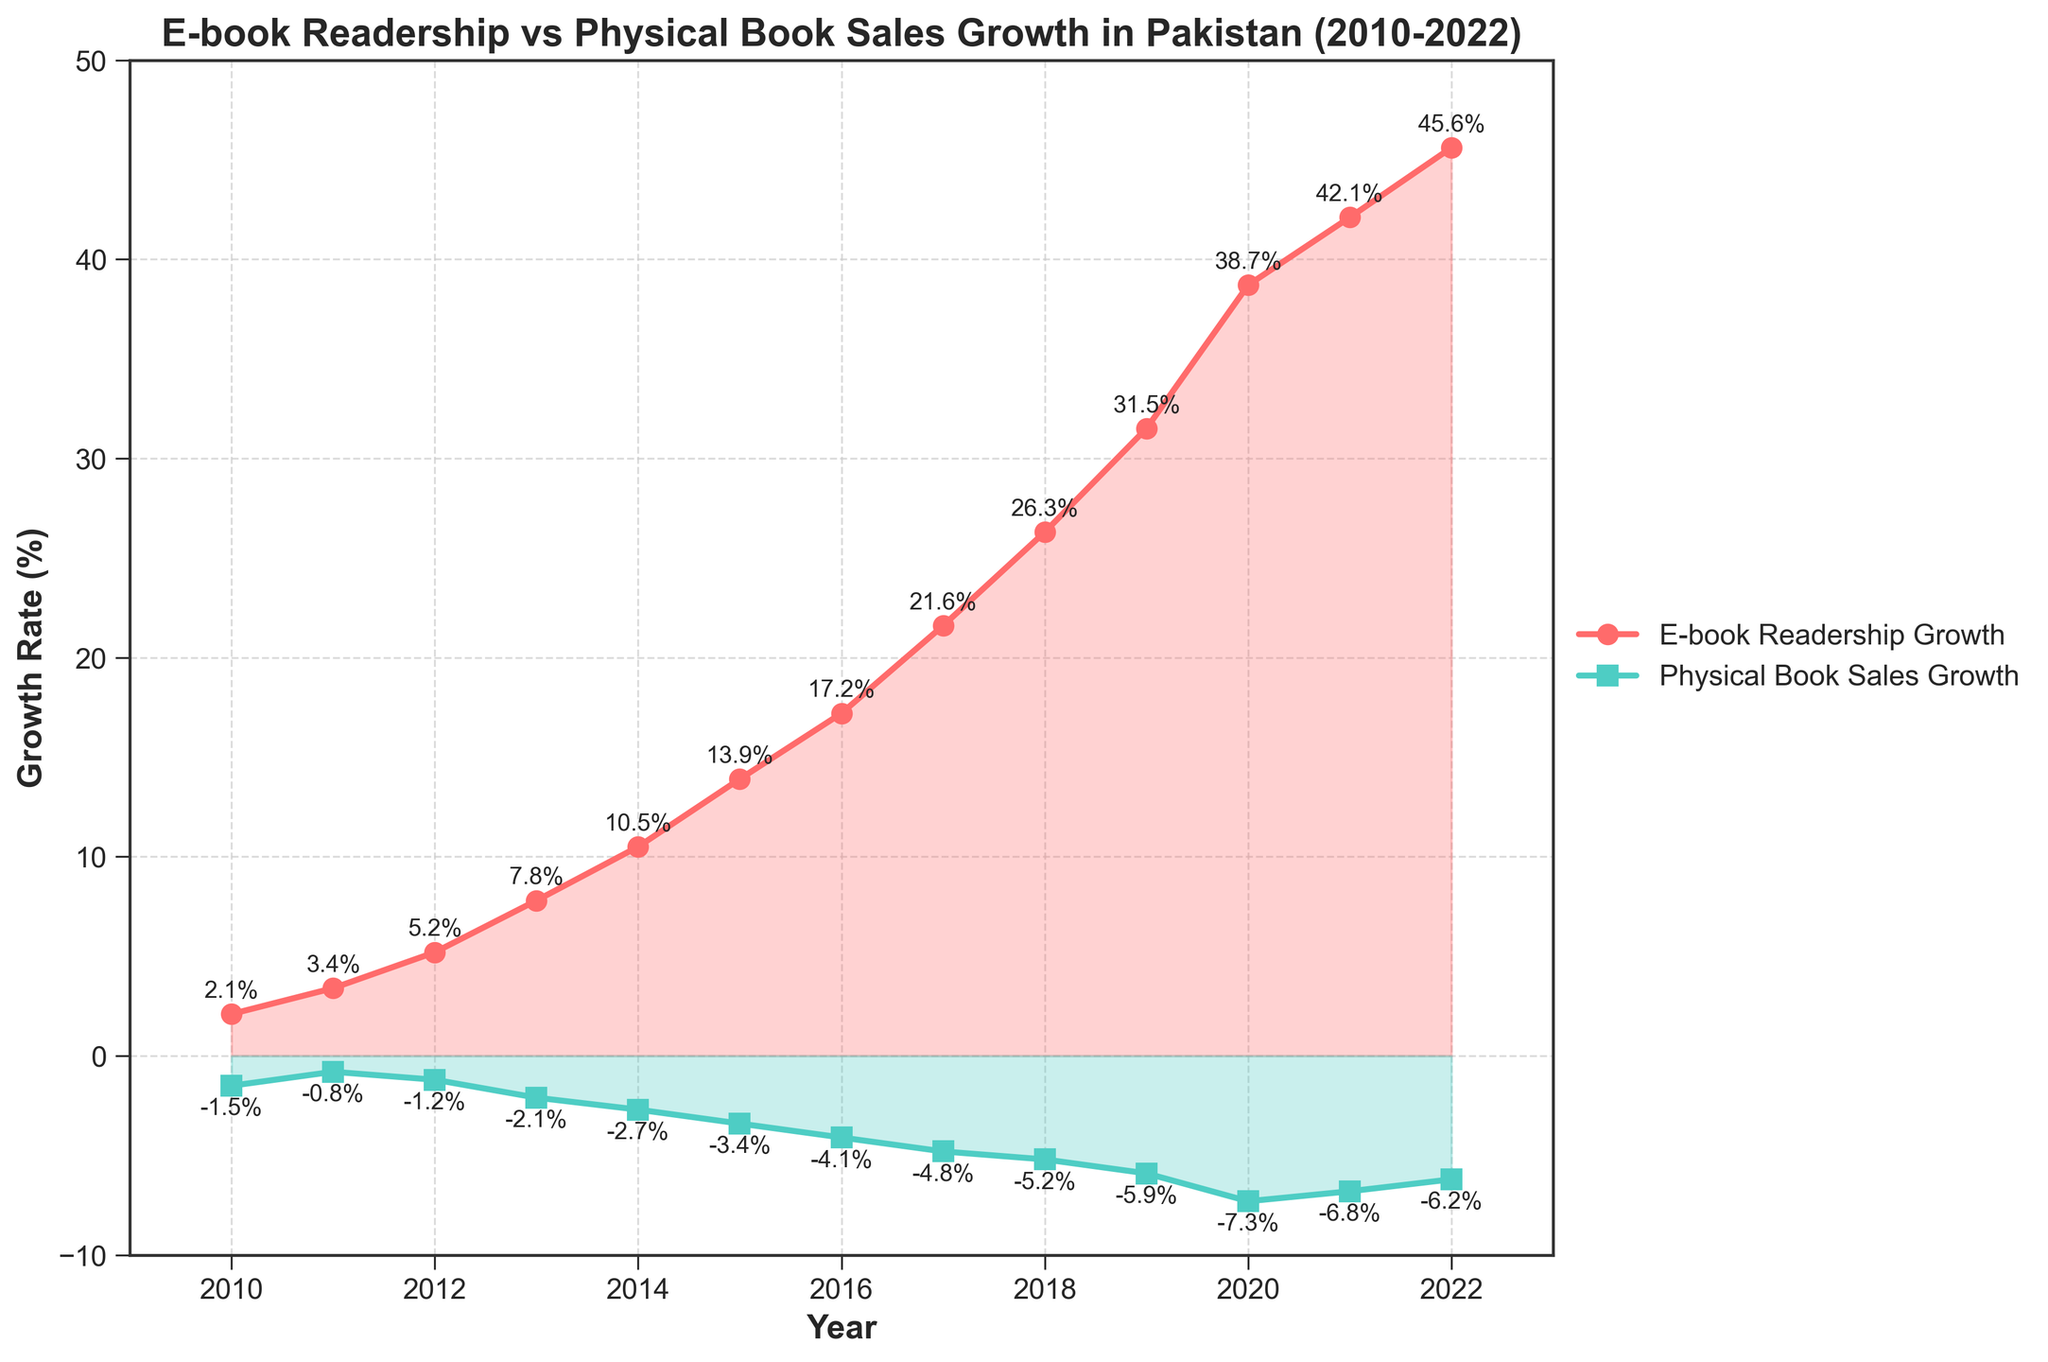What is the general trend of e-book readership growth from 2010 to 2022? The e-book readership growth depicted by the red line shows a consistently increasing trend from 2010 to 2022. Initially, it starts at 2.1% in 2010 and ends at 45.6% in 2022, indicating a significant rise over the years.
Answer: Increasing How has physical book sales growth changed from 2010 to 2022? The physical book sales growth, represented by the green line, demonstrates a continuous decrease from 2010 to 2022. It begins at -1.5% in 2010 and reaches -6.2% by 2022, marking a steady decline.
Answer: Decreasing In which year did e-book readership growth surpass 20% for the first time? According to the chart, e-book readership growth first surpasses 20% in 2017, where it is marked at 21.6%.
Answer: 2017 What is the average growth rate of physical book sales between 2010 and 2022? To find the average, sum all the growth rates of physical book sales from 2010 to 2022 and divide by the number of years. The sum is -1.5 - 0.8 - 1.2 - 2.1 - 2.7 - 3.4 - 4.1 - 4.8 - 5.2 - 5.9 - 7.3 - 6.8 - 6.2 = -52. Under the span of 13 years: -52/13 ≈ -4
Answer: -4 Compare the growth of e-book readership and physical book sales in the year 2020. In 2020, the e-book readership growth rate was 38.7%, while the physical book sales growth rate was -7.3%. E-book readership growth was significantly higher (45.6%) compared to physical book sales (-6.2%).
Answer: E-book readership (38.7%) > Physical book sales (-7.3%) How much did the e-book readership growth rate increase from 2010 to 2022? To find the increase, subtract the e-book readership growth rate in 2010 from that in 2022. 45.6% (2022) - 2.1% (2010) = 43.5%
Answer: 43.5% What is the difference in growth rates between e-books and physical books in 2016? In 2016, the growth rate for e-books is 17.2% and for physical books is -4.1%. The difference can be calculated as 17.2% - (-4.1%) = 21.3%.
Answer: 21.3% Which year shows the most significant decline in physical book sales, and what is the rate? The most significant decline in physical book sales is observed in 2020, where the growth rate is -7.3%.
Answer: 2020 at -7.3% What is the approximate visual difference between the highest e-book readership growth rate and the lowest physical book sales growth rate? Visually, the highest e-book readership growth is about 45.6% in 2022, and the lowest physical book sales growth is approximately -7.3% in 2020. The difference can be calculated as 45.6 - (-7.3) = 52.9%.
Answer: 52.9% 